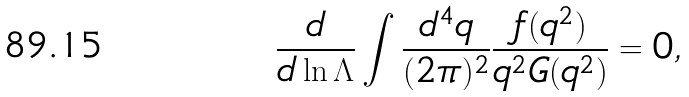<formula> <loc_0><loc_0><loc_500><loc_500>\frac { d } { d \ln \Lambda } \int \frac { d ^ { 4 } q } { ( 2 \pi ) ^ { 2 } } \frac { f ( q ^ { 2 } ) } { q ^ { 2 } G ( q ^ { 2 } ) } = 0 ,</formula> 